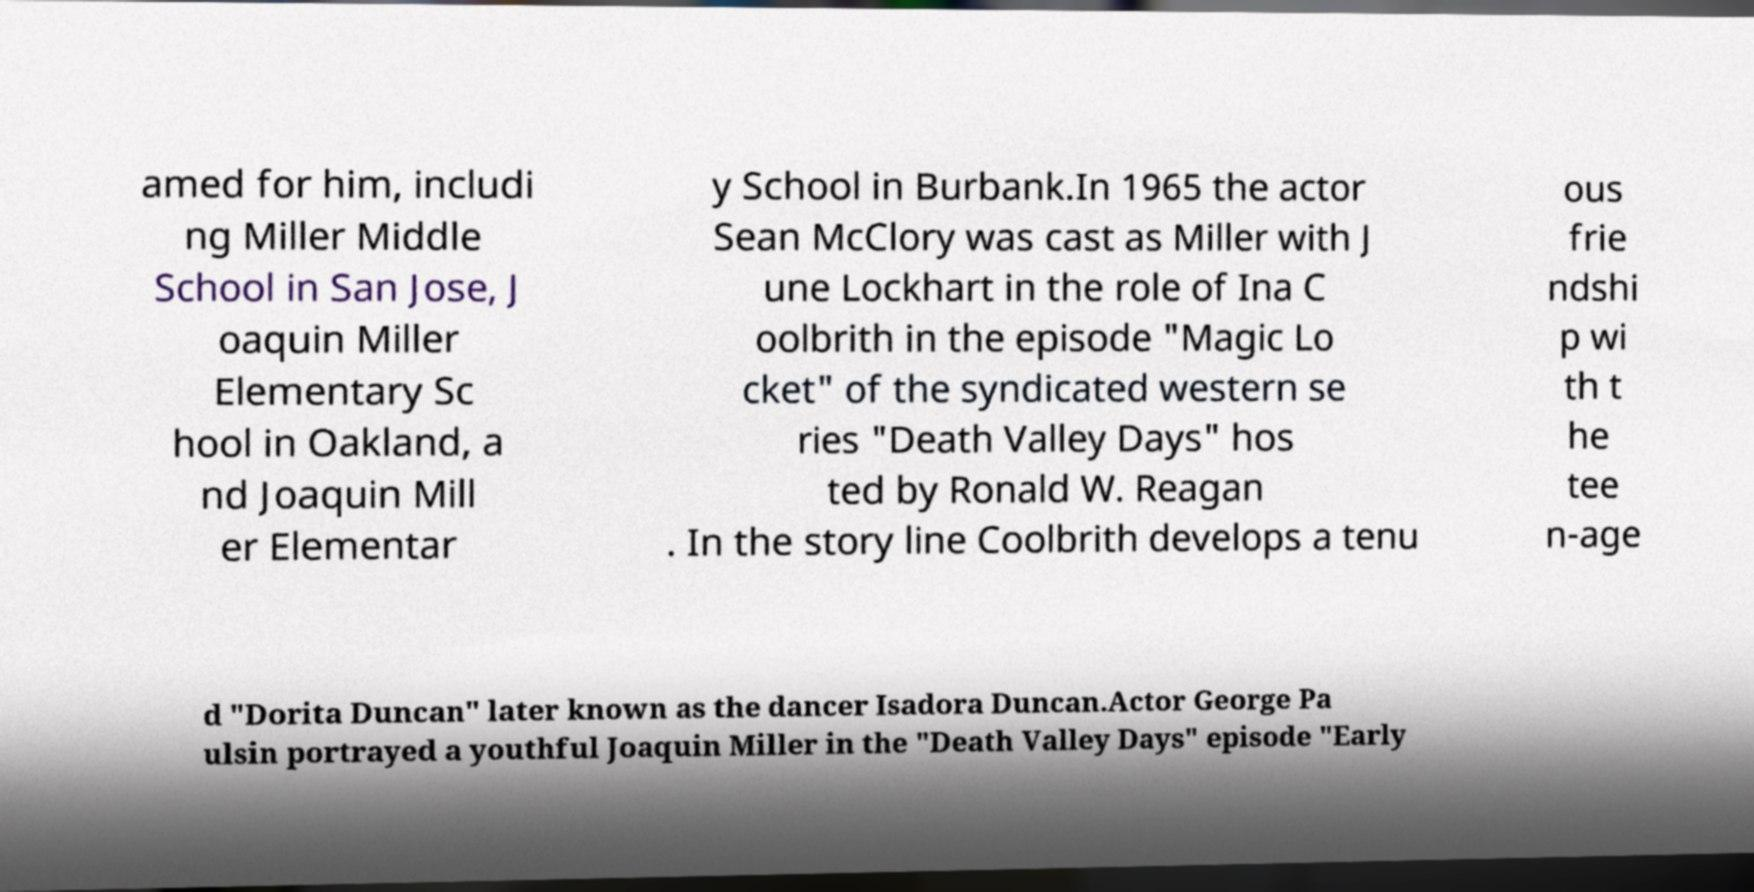Please read and relay the text visible in this image. What does it say? amed for him, includi ng Miller Middle School in San Jose, J oaquin Miller Elementary Sc hool in Oakland, a nd Joaquin Mill er Elementar y School in Burbank.In 1965 the actor Sean McClory was cast as Miller with J une Lockhart in the role of Ina C oolbrith in the episode "Magic Lo cket" of the syndicated western se ries "Death Valley Days" hos ted by Ronald W. Reagan . In the story line Coolbrith develops a tenu ous frie ndshi p wi th t he tee n-age d "Dorita Duncan" later known as the dancer Isadora Duncan.Actor George Pa ulsin portrayed a youthful Joaquin Miller in the "Death Valley Days" episode "Early 